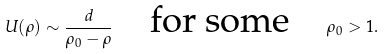Convert formula to latex. <formula><loc_0><loc_0><loc_500><loc_500>U ( \rho ) \sim \frac { d } { \rho _ { 0 } - \rho } \quad \text {for some} \quad \rho _ { 0 } > 1 .</formula> 